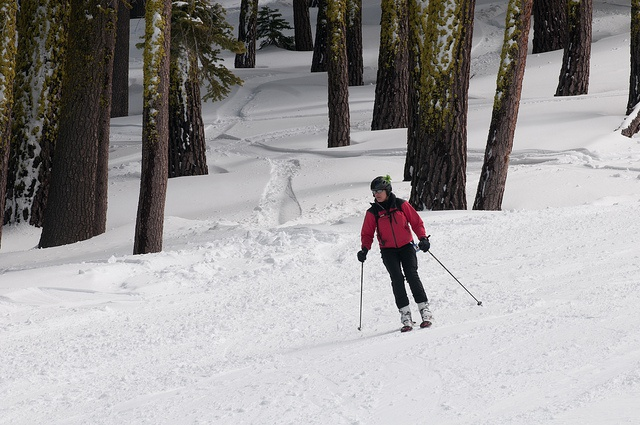Describe the objects in this image and their specific colors. I can see people in darkgreen, black, maroon, brown, and darkgray tones and skis in darkgreen, black, gray, darkgray, and lightgray tones in this image. 